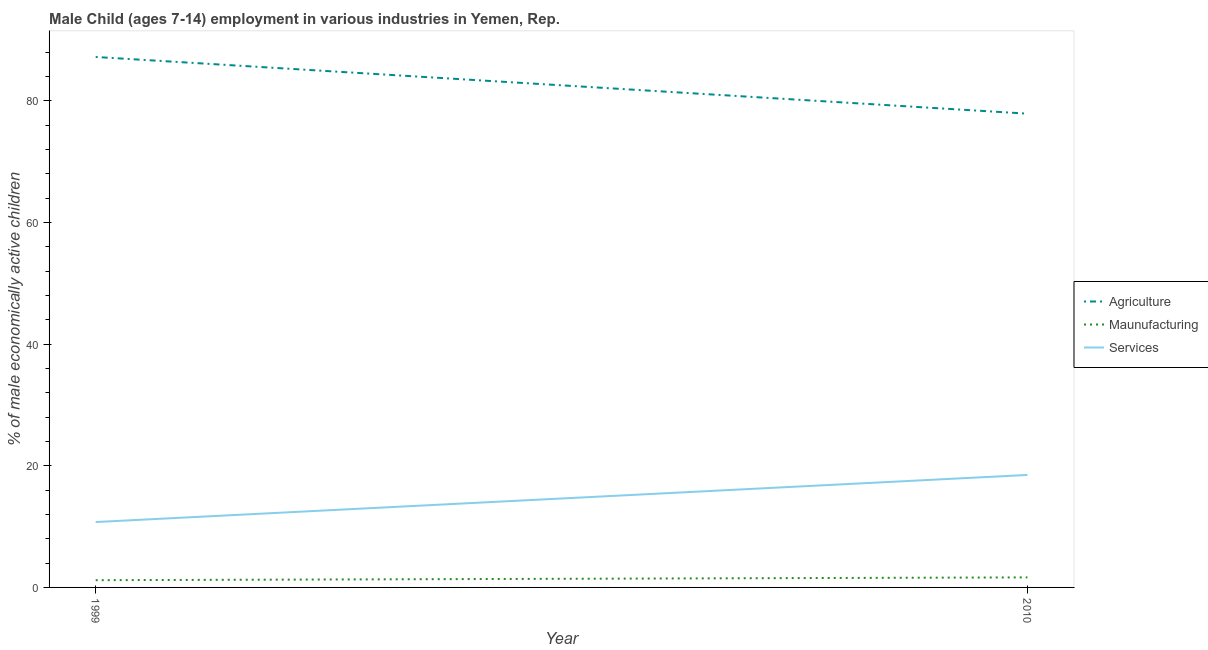How many different coloured lines are there?
Your answer should be compact. 3. What is the percentage of economically active children in services in 2010?
Your response must be concise. 18.49. Across all years, what is the maximum percentage of economically active children in agriculture?
Make the answer very short. 87.21. Across all years, what is the minimum percentage of economically active children in agriculture?
Ensure brevity in your answer.  77.89. In which year was the percentage of economically active children in services maximum?
Offer a terse response. 2010. What is the total percentage of economically active children in services in the graph?
Ensure brevity in your answer.  29.24. What is the difference between the percentage of economically active children in agriculture in 1999 and that in 2010?
Provide a short and direct response. 9.32. What is the difference between the percentage of economically active children in agriculture in 2010 and the percentage of economically active children in manufacturing in 1999?
Your response must be concise. 76.7. What is the average percentage of economically active children in services per year?
Offer a terse response. 14.62. In the year 1999, what is the difference between the percentage of economically active children in manufacturing and percentage of economically active children in services?
Provide a succinct answer. -9.56. What is the ratio of the percentage of economically active children in manufacturing in 1999 to that in 2010?
Your response must be concise. 0.72. Is the percentage of economically active children in manufacturing in 1999 less than that in 2010?
Provide a short and direct response. Yes. Is it the case that in every year, the sum of the percentage of economically active children in agriculture and percentage of economically active children in manufacturing is greater than the percentage of economically active children in services?
Give a very brief answer. Yes. Does the percentage of economically active children in services monotonically increase over the years?
Your response must be concise. Yes. How many lines are there?
Make the answer very short. 3. What is the difference between two consecutive major ticks on the Y-axis?
Make the answer very short. 20. Are the values on the major ticks of Y-axis written in scientific E-notation?
Give a very brief answer. No. Where does the legend appear in the graph?
Provide a succinct answer. Center right. How are the legend labels stacked?
Your answer should be very brief. Vertical. What is the title of the graph?
Your response must be concise. Male Child (ages 7-14) employment in various industries in Yemen, Rep. Does "Social Protection and Labor" appear as one of the legend labels in the graph?
Keep it short and to the point. No. What is the label or title of the Y-axis?
Give a very brief answer. % of male economically active children. What is the % of male economically active children in Agriculture in 1999?
Your response must be concise. 87.21. What is the % of male economically active children of Maunufacturing in 1999?
Your answer should be very brief. 1.19. What is the % of male economically active children of Services in 1999?
Provide a short and direct response. 10.75. What is the % of male economically active children in Agriculture in 2010?
Offer a terse response. 77.89. What is the % of male economically active children of Maunufacturing in 2010?
Provide a succinct answer. 1.65. What is the % of male economically active children in Services in 2010?
Provide a succinct answer. 18.49. Across all years, what is the maximum % of male economically active children in Agriculture?
Keep it short and to the point. 87.21. Across all years, what is the maximum % of male economically active children in Maunufacturing?
Make the answer very short. 1.65. Across all years, what is the maximum % of male economically active children in Services?
Offer a very short reply. 18.49. Across all years, what is the minimum % of male economically active children in Agriculture?
Provide a succinct answer. 77.89. Across all years, what is the minimum % of male economically active children of Maunufacturing?
Provide a succinct answer. 1.19. Across all years, what is the minimum % of male economically active children of Services?
Your response must be concise. 10.75. What is the total % of male economically active children of Agriculture in the graph?
Make the answer very short. 165.1. What is the total % of male economically active children of Maunufacturing in the graph?
Ensure brevity in your answer.  2.84. What is the total % of male economically active children of Services in the graph?
Provide a succinct answer. 29.24. What is the difference between the % of male economically active children in Agriculture in 1999 and that in 2010?
Offer a very short reply. 9.32. What is the difference between the % of male economically active children in Maunufacturing in 1999 and that in 2010?
Your response must be concise. -0.46. What is the difference between the % of male economically active children of Services in 1999 and that in 2010?
Make the answer very short. -7.74. What is the difference between the % of male economically active children of Agriculture in 1999 and the % of male economically active children of Maunufacturing in 2010?
Make the answer very short. 85.56. What is the difference between the % of male economically active children in Agriculture in 1999 and the % of male economically active children in Services in 2010?
Offer a terse response. 68.72. What is the difference between the % of male economically active children in Maunufacturing in 1999 and the % of male economically active children in Services in 2010?
Ensure brevity in your answer.  -17.3. What is the average % of male economically active children in Agriculture per year?
Give a very brief answer. 82.55. What is the average % of male economically active children of Maunufacturing per year?
Offer a terse response. 1.42. What is the average % of male economically active children of Services per year?
Your response must be concise. 14.62. In the year 1999, what is the difference between the % of male economically active children of Agriculture and % of male economically active children of Maunufacturing?
Provide a short and direct response. 86.02. In the year 1999, what is the difference between the % of male economically active children in Agriculture and % of male economically active children in Services?
Provide a succinct answer. 76.46. In the year 1999, what is the difference between the % of male economically active children in Maunufacturing and % of male economically active children in Services?
Your response must be concise. -9.56. In the year 2010, what is the difference between the % of male economically active children of Agriculture and % of male economically active children of Maunufacturing?
Give a very brief answer. 76.24. In the year 2010, what is the difference between the % of male economically active children in Agriculture and % of male economically active children in Services?
Give a very brief answer. 59.4. In the year 2010, what is the difference between the % of male economically active children in Maunufacturing and % of male economically active children in Services?
Keep it short and to the point. -16.84. What is the ratio of the % of male economically active children in Agriculture in 1999 to that in 2010?
Offer a very short reply. 1.12. What is the ratio of the % of male economically active children in Maunufacturing in 1999 to that in 2010?
Give a very brief answer. 0.72. What is the ratio of the % of male economically active children in Services in 1999 to that in 2010?
Your answer should be very brief. 0.58. What is the difference between the highest and the second highest % of male economically active children in Agriculture?
Make the answer very short. 9.32. What is the difference between the highest and the second highest % of male economically active children in Maunufacturing?
Your answer should be compact. 0.46. What is the difference between the highest and the second highest % of male economically active children in Services?
Provide a short and direct response. 7.74. What is the difference between the highest and the lowest % of male economically active children of Agriculture?
Give a very brief answer. 9.32. What is the difference between the highest and the lowest % of male economically active children in Maunufacturing?
Your answer should be very brief. 0.46. What is the difference between the highest and the lowest % of male economically active children of Services?
Make the answer very short. 7.74. 